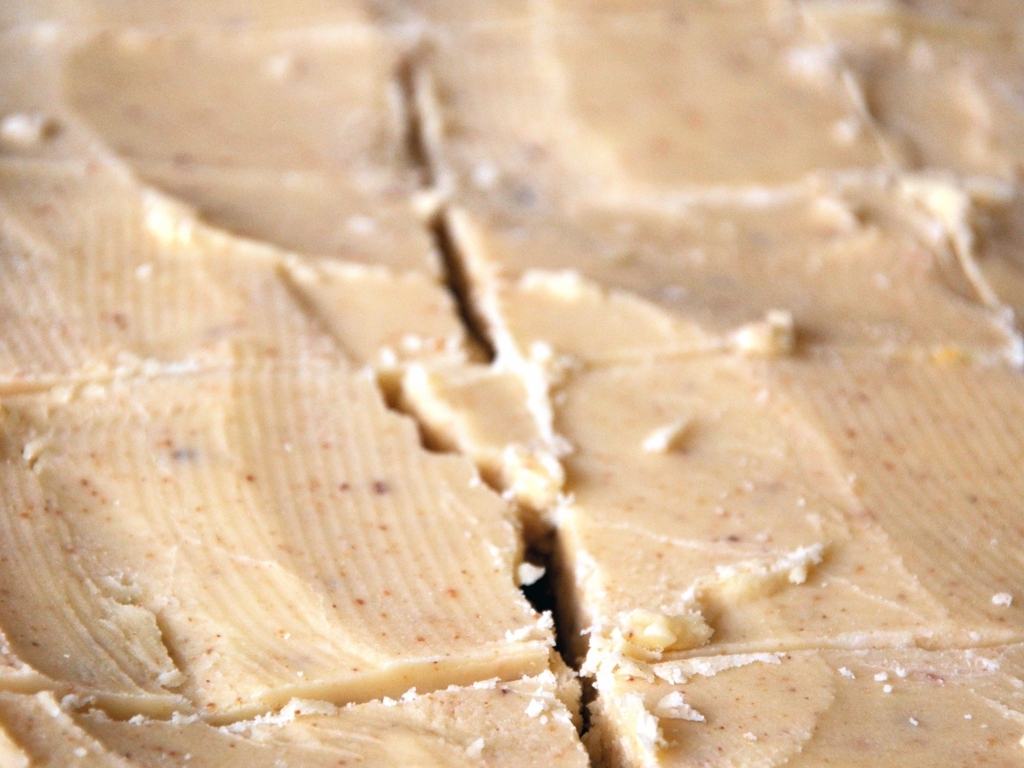Could you suggest ways this image could be used? This image could be used for culinary websites or blogs as a visual aid to discuss spreads or for articles about baking and cooking to illustrate the texture and consistency of ingredients used in recipes. What type of recipes would benefit from using this particular substance? Recipes that could benefit from this substance might include baked goods such as breads, pastries, or cookies where it can be used as a spread, or in cooking to enhance flavor in sauces or as a base in skillet dishes. 